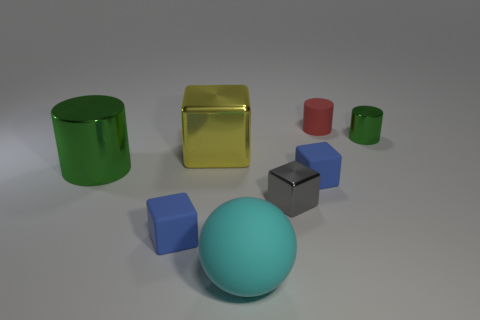Add 1 small gray metallic blocks. How many objects exist? 9 Subtract all cylinders. How many objects are left? 5 Add 4 yellow shiny blocks. How many yellow shiny blocks are left? 5 Add 1 tiny brown matte spheres. How many tiny brown matte spheres exist? 1 Subtract 0 purple spheres. How many objects are left? 8 Subtract all gray rubber balls. Subtract all tiny blue rubber cubes. How many objects are left? 6 